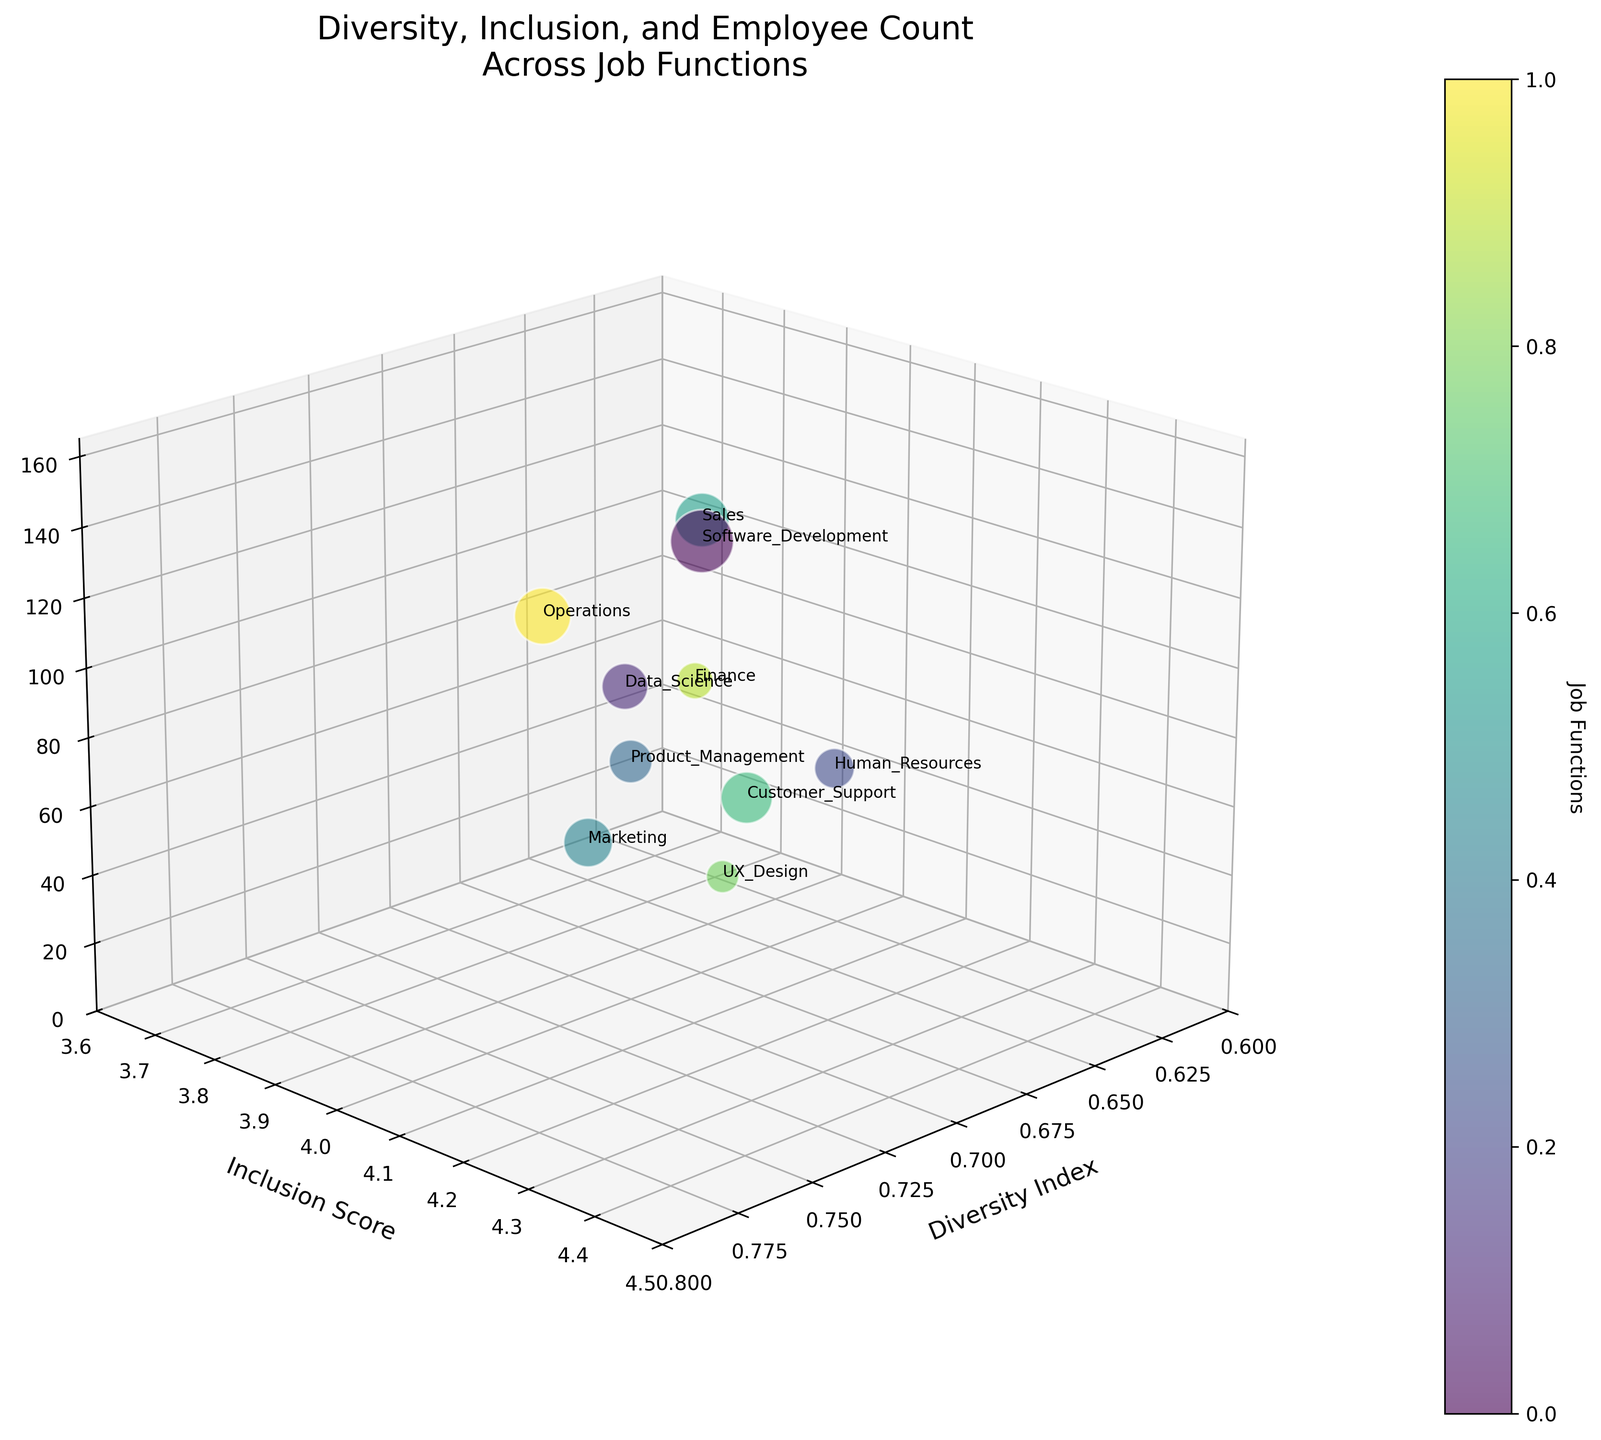What is the title of the 3D bubble chart? The title is usually placed at the top of the chart. The chart's title is "Diversity, Inclusion, and Employee Count Across Job Functions".
Answer: Diversity, Inclusion, and Employee Count Across Job Functions What are the axes labels on the 3D bubble chart? The labels of the axes are typically shown along each axis line. In this case, they are "Diversity Index" on the x-axis, "Inclusion Score" on the y-axis, and "Employee Count" on the z-axis.
Answer: Diversity Index, Inclusion Score, Employee Count Which job function has the highest inclusion score? By looking at the y-axis and identifying the highest point, and finding which bubble is labeled with the corresponding job function, we see that "Customer Support" in Toronto has an Inclusion Score of 4.4, which is the highest.
Answer: Customer Support How many different job functions are represented in the chart? Each bubble represents a different job function, and there is one text label for each job function. Counting the different labels, there are 10 unique job functions depicted.
Answer: 10 Which job function has the largest employee count, and where is it located? Employee count is represented by the z-axis, and the largest bubble represents the largest employee count. The "Software Development" job function has the largest bubble at 150 employees, located in San Francisco.
Answer: Software Development, San Francisco What's the average inclusion score across all job functions? The inclusion scores are: 4.2, 3.9, 4.1, 4.0, 4.3, 3.8, 4.4, 4.1, 3.7, 4.0. Summing these up gives 40.5, and there are 10 job functions, thus the average is 40.5 / 10 = 4.05.
Answer: 4.05 Compare the diversity index of "Marketing" and "Finance". Which one is higher? By locating "Marketing" and "Finance" on the chart, we see that the diversity index for Marketing is 0.78 and for Finance is 0.61. Marketing has the higher diversity index.
Answer: Marketing Which job function has both a diversity index greater than 0.7 and an inclusion score greater than 4.1? Looking at bubbles with both criteria: Diversity Index > 0.7 and Inclusion Score > 4.1, we find "Customer Support" with a diversity index of 0.75 and an inclusion score of 4.4.
Answer: Customer Support Which job function in the age group 25-34 has the highest diversity index? In the age group 25-34, look at the diversity indices: Software Development (0.72), Product Management (0.70), Customer Support (0.75), and Operations (0.73). Customer Support has the highest at 0.75.
Answer: Customer Support 